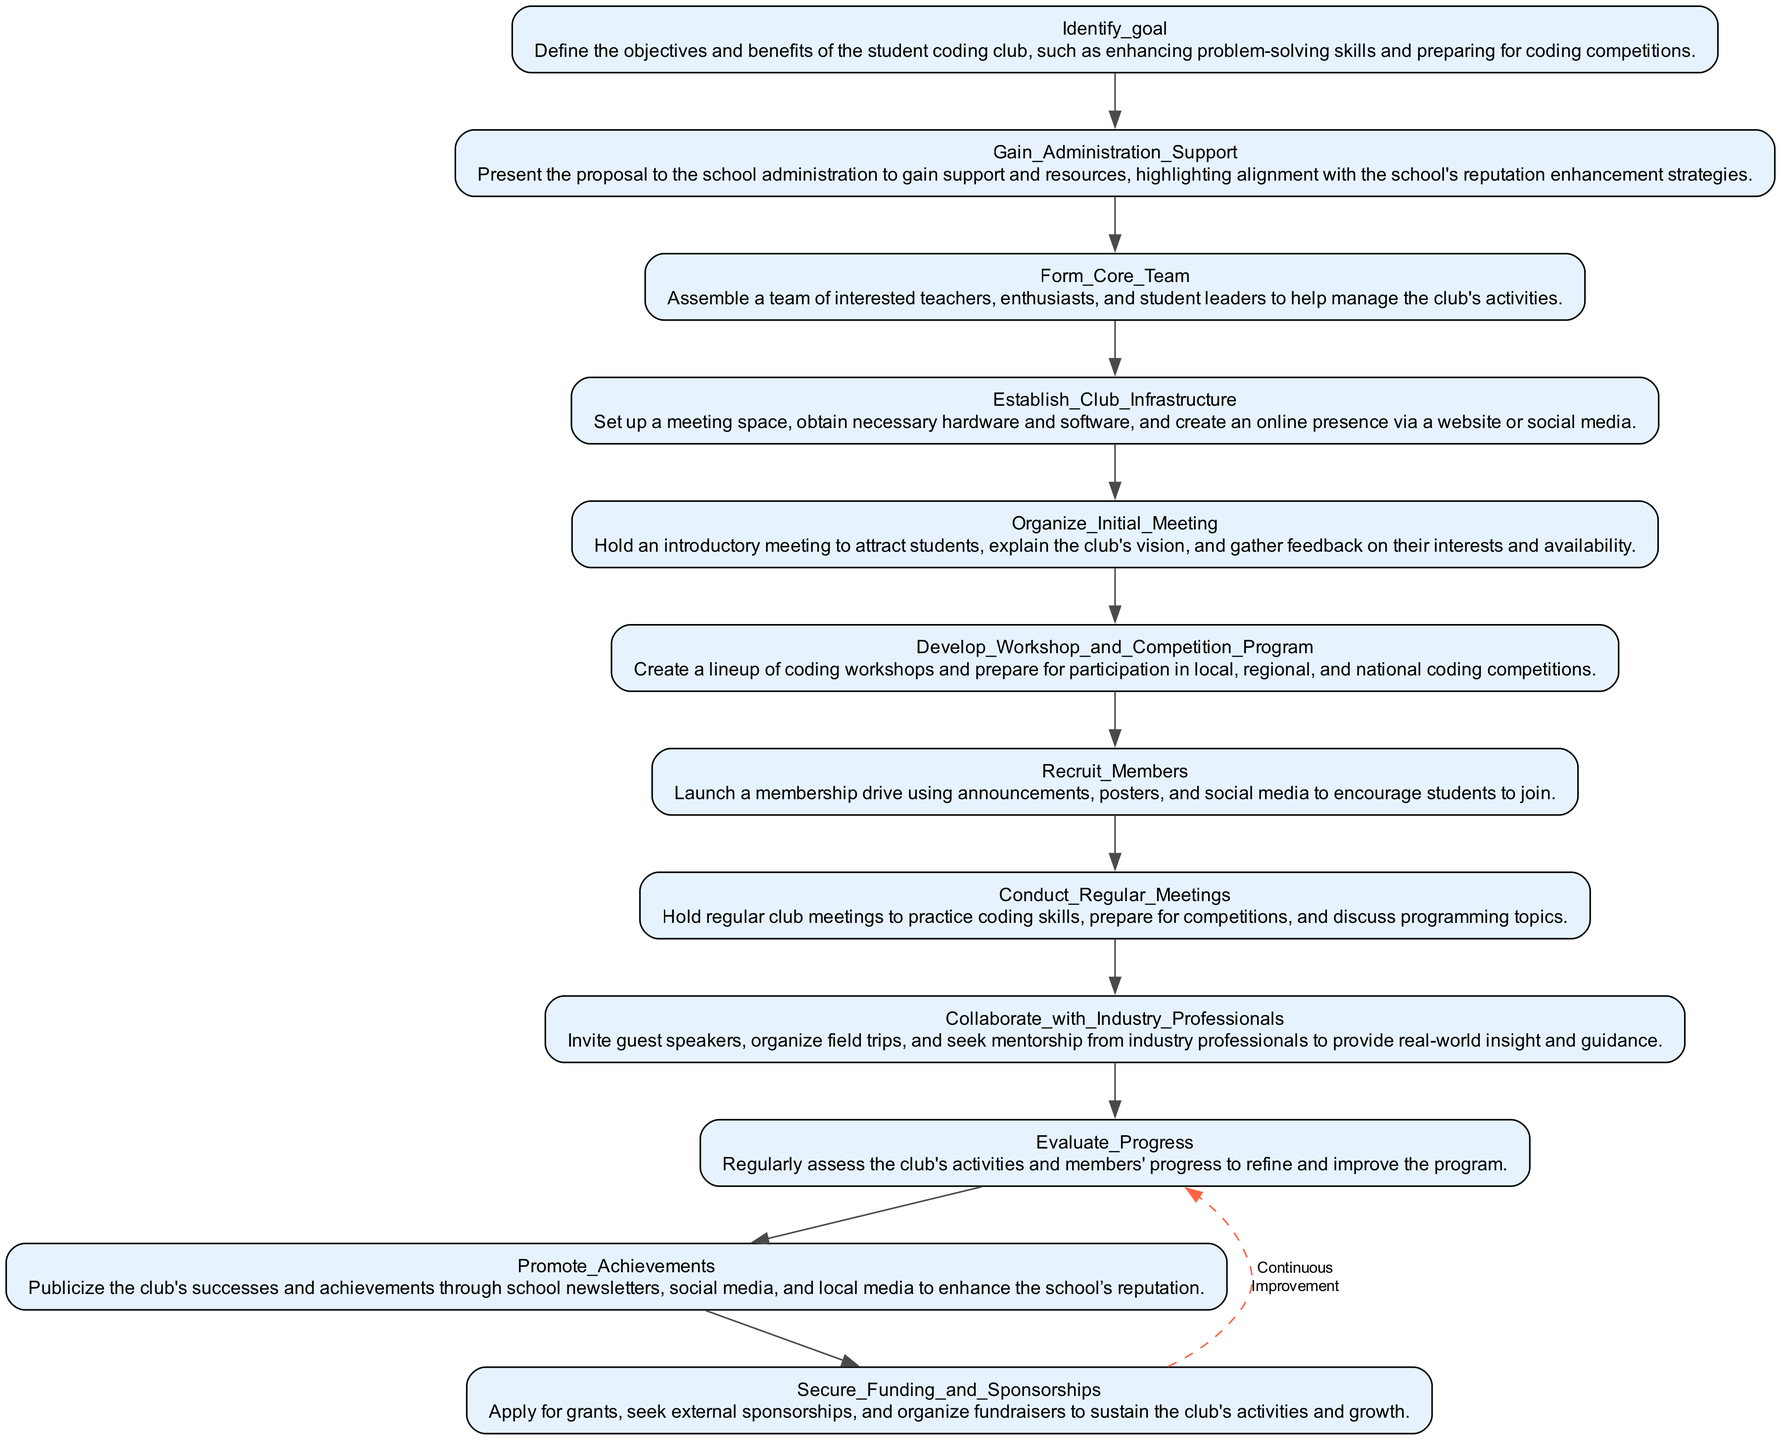What is the first step in the flowchart? The first step in the flowchart is "Identify_goal," which defines the objectives and benefits of the student coding club. This is found at the top of the diagram.
Answer: Identify goal How many main steps are outlined in the diagram? The diagram outlines a total of 12 main steps, which can be counted as individual nodes in the flowchart from start to conclusion.
Answer: 12 What follows after "Organize_Initial_Meeting"? After "Organize_Initial_Meeting," the next step is "Develop_Workshop_and_Competition_Program." This follows the sequential flow indicated in the diagram.
Answer: Develop Workshop and Competition Program What is the last step the diagram indicates? The last step in the flowchart is "Secure_Funding_and_Sponsorships," which is positioned at the end of the sequence of steps.
Answer: Secure Funding and Sponsorships Which step involves publicizing the club's successes? The step that involves publicizing the club's successes is "Promote_Achievements." It highlights the importance of sharing successes to enhance the school's reputation.
Answer: Promote Achievements Which two steps focus on collaboration with outside entities? The two steps that focus on collaboration with outside entities are "Collaborate_with_Industry_Professionals" and "Gain_Administration_Support." Both steps emphasize engaging with external parties for support and resources.
Answer: Collaborate with Industry Professionals and Gain Administration Support What process signifies ongoing improvement according to the diagram? The process that signifies ongoing improvement is represented by the dashed line connecting the last node back to "Evaluate_Progress." This indicates a continuous feedback loop for refinement.
Answer: Continuous Improvement Which phase is responsible for setting up the needed infrastructure for the club? The phase responsible for setting up the needed infrastructure is "Establish_Club_Infrastructure." This step focuses on arranging the necessary physical and online resources.
Answer: Establish Club Infrastructure Which node highlights the aspect of bringing in real-world experience? The node that highlights the aspect of bringing in real-world experience is "Collaborate_with_Industry_Professionals," as it invites outside expertise into the club’s activities.
Answer: Collaborate with Industry Professionals 